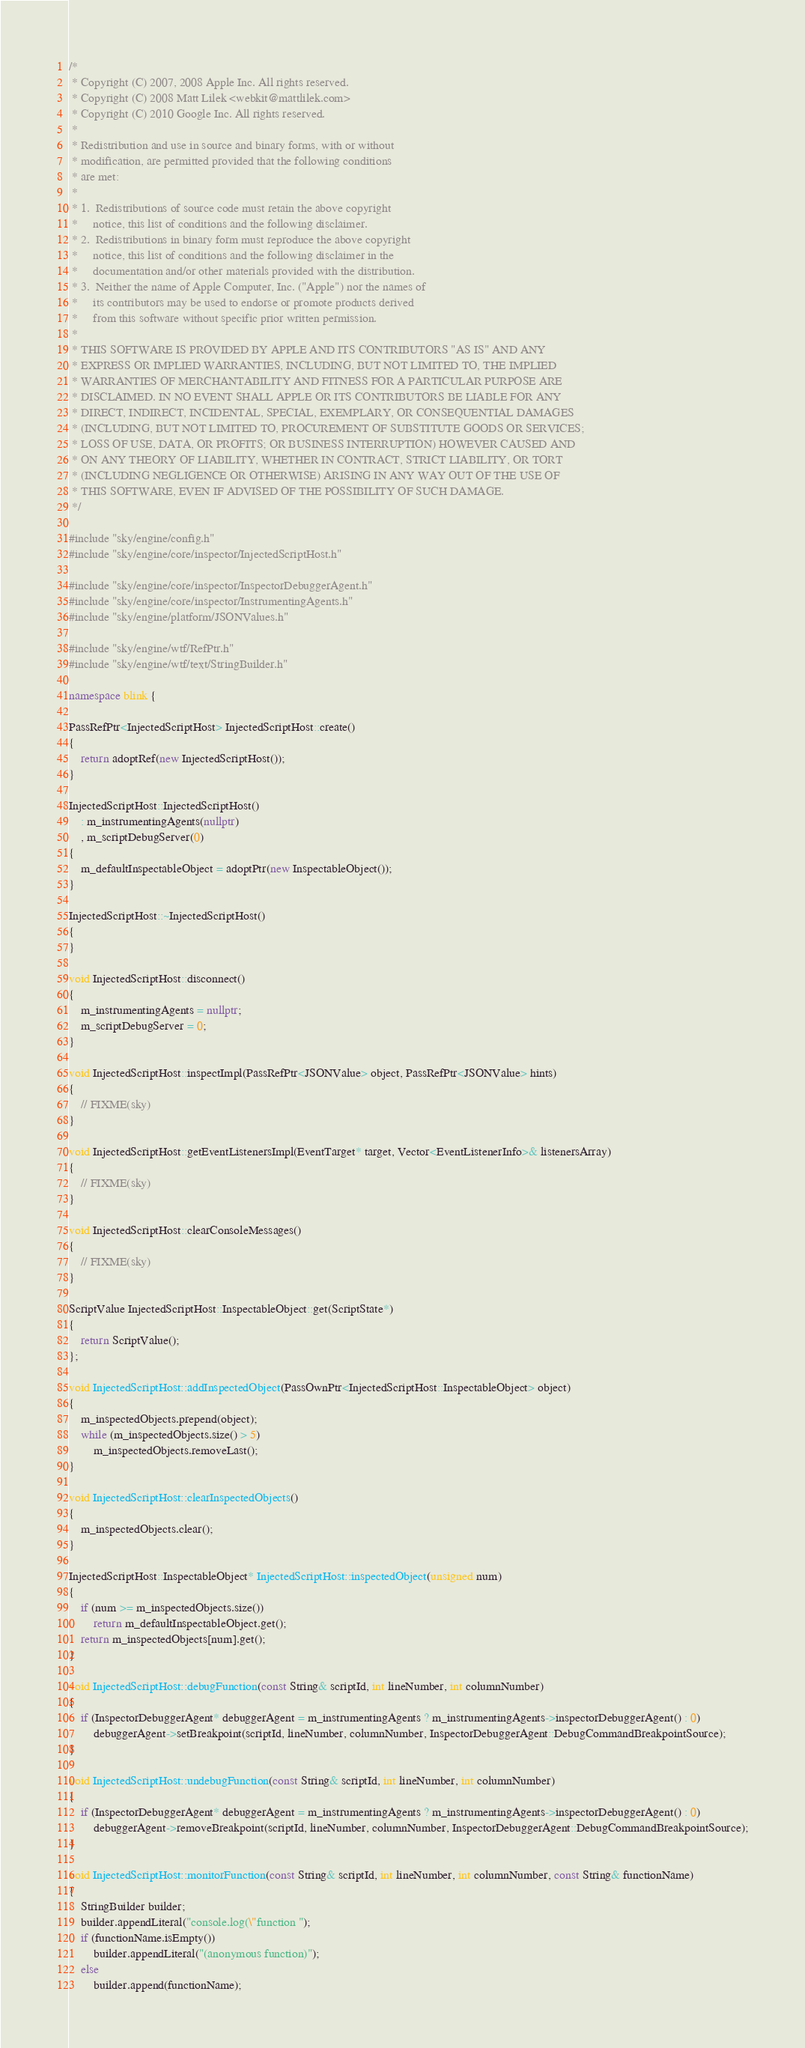Convert code to text. <code><loc_0><loc_0><loc_500><loc_500><_C++_>/*
 * Copyright (C) 2007, 2008 Apple Inc. All rights reserved.
 * Copyright (C) 2008 Matt Lilek <webkit@mattlilek.com>
 * Copyright (C) 2010 Google Inc. All rights reserved.
 *
 * Redistribution and use in source and binary forms, with or without
 * modification, are permitted provided that the following conditions
 * are met:
 *
 * 1.  Redistributions of source code must retain the above copyright
 *     notice, this list of conditions and the following disclaimer.
 * 2.  Redistributions in binary form must reproduce the above copyright
 *     notice, this list of conditions and the following disclaimer in the
 *     documentation and/or other materials provided with the distribution.
 * 3.  Neither the name of Apple Computer, Inc. ("Apple") nor the names of
 *     its contributors may be used to endorse or promote products derived
 *     from this software without specific prior written permission.
 *
 * THIS SOFTWARE IS PROVIDED BY APPLE AND ITS CONTRIBUTORS "AS IS" AND ANY
 * EXPRESS OR IMPLIED WARRANTIES, INCLUDING, BUT NOT LIMITED TO, THE IMPLIED
 * WARRANTIES OF MERCHANTABILITY AND FITNESS FOR A PARTICULAR PURPOSE ARE
 * DISCLAIMED. IN NO EVENT SHALL APPLE OR ITS CONTRIBUTORS BE LIABLE FOR ANY
 * DIRECT, INDIRECT, INCIDENTAL, SPECIAL, EXEMPLARY, OR CONSEQUENTIAL DAMAGES
 * (INCLUDING, BUT NOT LIMITED TO, PROCUREMENT OF SUBSTITUTE GOODS OR SERVICES;
 * LOSS OF USE, DATA, OR PROFITS; OR BUSINESS INTERRUPTION) HOWEVER CAUSED AND
 * ON ANY THEORY OF LIABILITY, WHETHER IN CONTRACT, STRICT LIABILITY, OR TORT
 * (INCLUDING NEGLIGENCE OR OTHERWISE) ARISING IN ANY WAY OUT OF THE USE OF
 * THIS SOFTWARE, EVEN IF ADVISED OF THE POSSIBILITY OF SUCH DAMAGE.
 */

#include "sky/engine/config.h"
#include "sky/engine/core/inspector/InjectedScriptHost.h"

#include "sky/engine/core/inspector/InspectorDebuggerAgent.h"
#include "sky/engine/core/inspector/InstrumentingAgents.h"
#include "sky/engine/platform/JSONValues.h"

#include "sky/engine/wtf/RefPtr.h"
#include "sky/engine/wtf/text/StringBuilder.h"

namespace blink {

PassRefPtr<InjectedScriptHost> InjectedScriptHost::create()
{
    return adoptRef(new InjectedScriptHost());
}

InjectedScriptHost::InjectedScriptHost()
    : m_instrumentingAgents(nullptr)
    , m_scriptDebugServer(0)
{
    m_defaultInspectableObject = adoptPtr(new InspectableObject());
}

InjectedScriptHost::~InjectedScriptHost()
{
}

void InjectedScriptHost::disconnect()
{
    m_instrumentingAgents = nullptr;
    m_scriptDebugServer = 0;
}

void InjectedScriptHost::inspectImpl(PassRefPtr<JSONValue> object, PassRefPtr<JSONValue> hints)
{
    // FIXME(sky)
}

void InjectedScriptHost::getEventListenersImpl(EventTarget* target, Vector<EventListenerInfo>& listenersArray)
{
    // FIXME(sky)
}

void InjectedScriptHost::clearConsoleMessages()
{
    // FIXME(sky)
}

ScriptValue InjectedScriptHost::InspectableObject::get(ScriptState*)
{
    return ScriptValue();
};

void InjectedScriptHost::addInspectedObject(PassOwnPtr<InjectedScriptHost::InspectableObject> object)
{
    m_inspectedObjects.prepend(object);
    while (m_inspectedObjects.size() > 5)
        m_inspectedObjects.removeLast();
}

void InjectedScriptHost::clearInspectedObjects()
{
    m_inspectedObjects.clear();
}

InjectedScriptHost::InspectableObject* InjectedScriptHost::inspectedObject(unsigned num)
{
    if (num >= m_inspectedObjects.size())
        return m_defaultInspectableObject.get();
    return m_inspectedObjects[num].get();
}

void InjectedScriptHost::debugFunction(const String& scriptId, int lineNumber, int columnNumber)
{
    if (InspectorDebuggerAgent* debuggerAgent = m_instrumentingAgents ? m_instrumentingAgents->inspectorDebuggerAgent() : 0)
        debuggerAgent->setBreakpoint(scriptId, lineNumber, columnNumber, InspectorDebuggerAgent::DebugCommandBreakpointSource);
}

void InjectedScriptHost::undebugFunction(const String& scriptId, int lineNumber, int columnNumber)
{
    if (InspectorDebuggerAgent* debuggerAgent = m_instrumentingAgents ? m_instrumentingAgents->inspectorDebuggerAgent() : 0)
        debuggerAgent->removeBreakpoint(scriptId, lineNumber, columnNumber, InspectorDebuggerAgent::DebugCommandBreakpointSource);
}

void InjectedScriptHost::monitorFunction(const String& scriptId, int lineNumber, int columnNumber, const String& functionName)
{
    StringBuilder builder;
    builder.appendLiteral("console.log(\"function ");
    if (functionName.isEmpty())
        builder.appendLiteral("(anonymous function)");
    else
        builder.append(functionName);</code> 